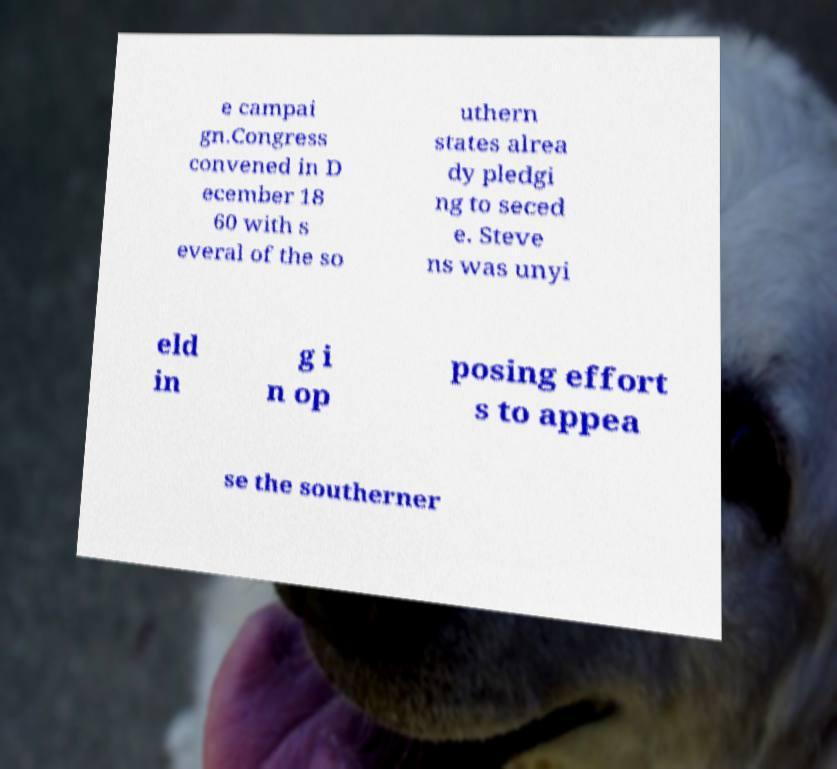Could you assist in decoding the text presented in this image and type it out clearly? e campai gn.Congress convened in D ecember 18 60 with s everal of the so uthern states alrea dy pledgi ng to seced e. Steve ns was unyi eld in g i n op posing effort s to appea se the southerner 